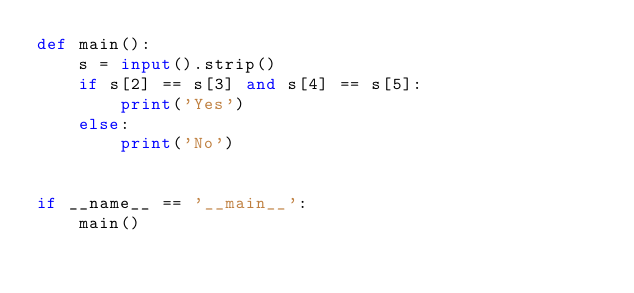<code> <loc_0><loc_0><loc_500><loc_500><_Python_>def main():
    s = input().strip()
    if s[2] == s[3] and s[4] == s[5]:
        print('Yes')
    else:
        print('No')


if __name__ == '__main__':
    main()
</code> 